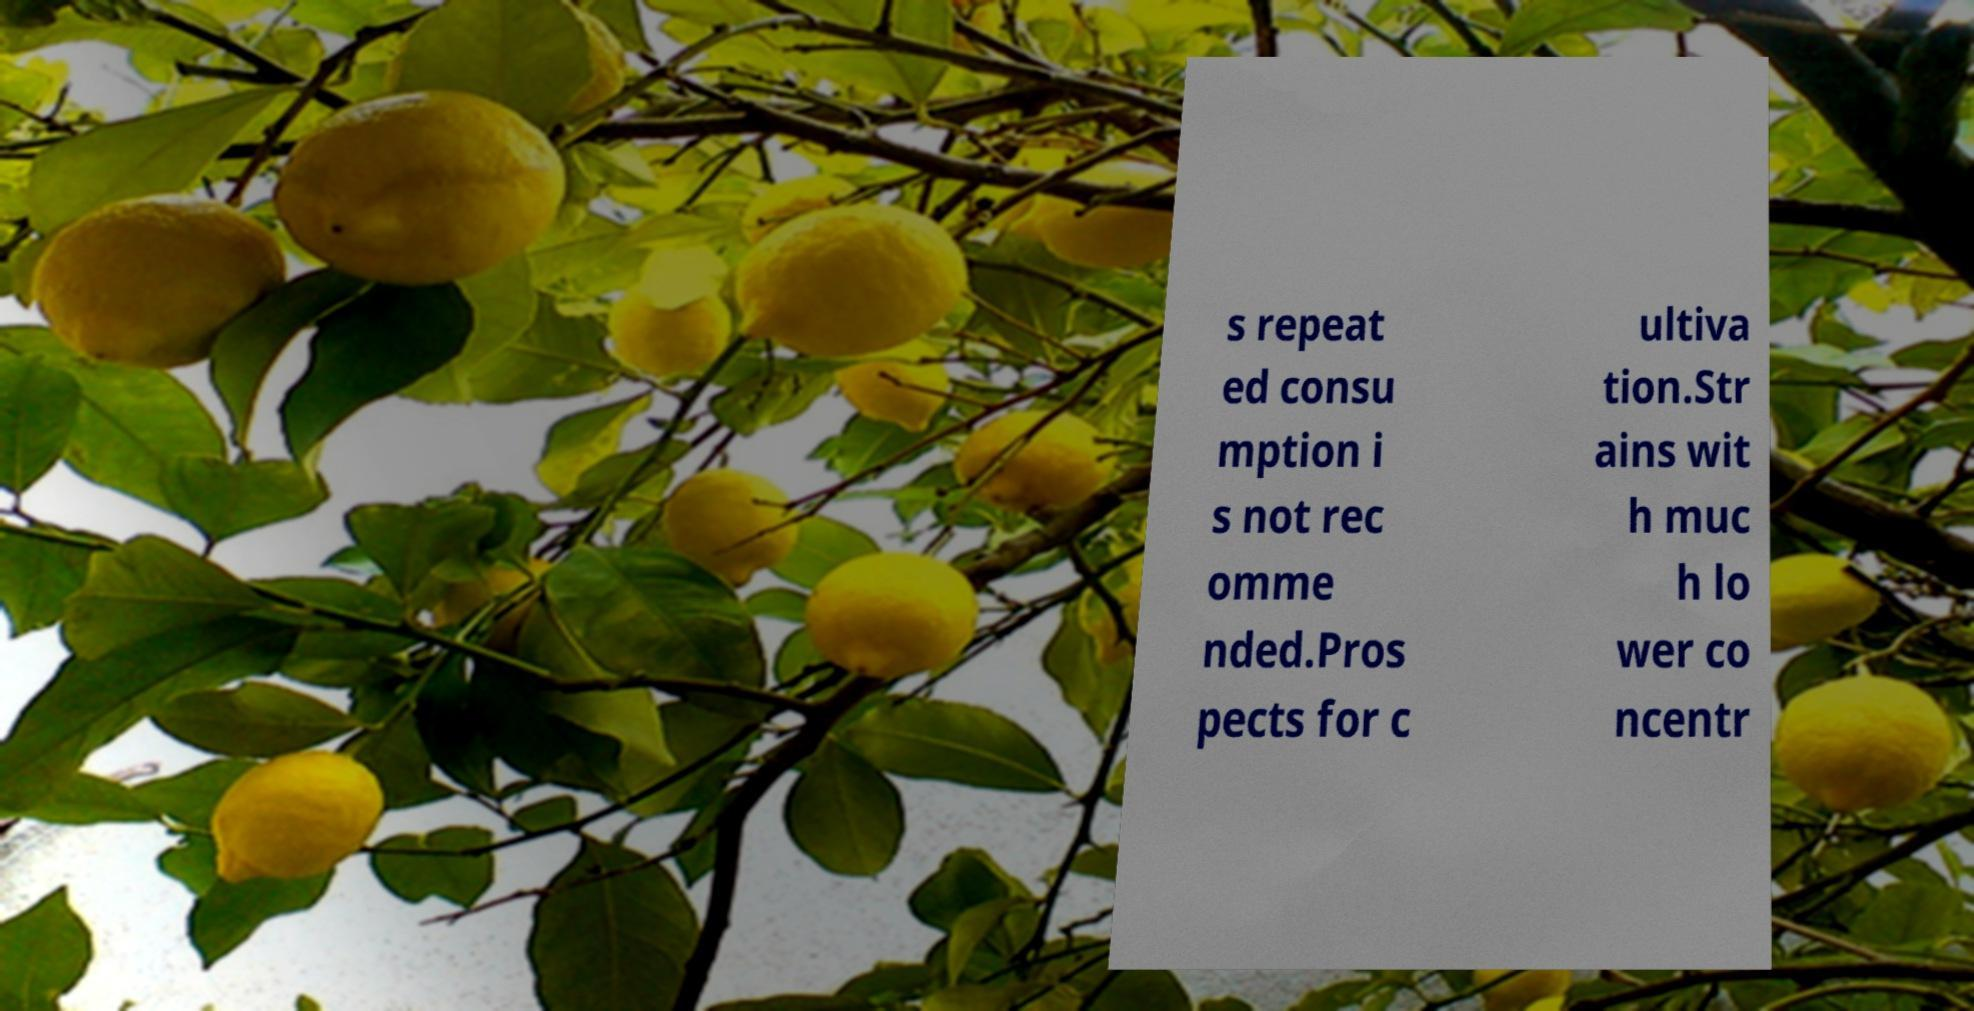Can you accurately transcribe the text from the provided image for me? s repeat ed consu mption i s not rec omme nded.Pros pects for c ultiva tion.Str ains wit h muc h lo wer co ncentr 